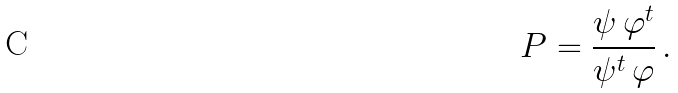<formula> <loc_0><loc_0><loc_500><loc_500>P = \frac { \psi \, \varphi ^ { t } } { \psi ^ { t } \, \varphi } \, .</formula> 